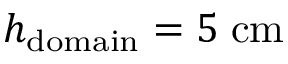<formula> <loc_0><loc_0><loc_500><loc_500>h _ { d o m a i n } = 5 \, c m</formula> 